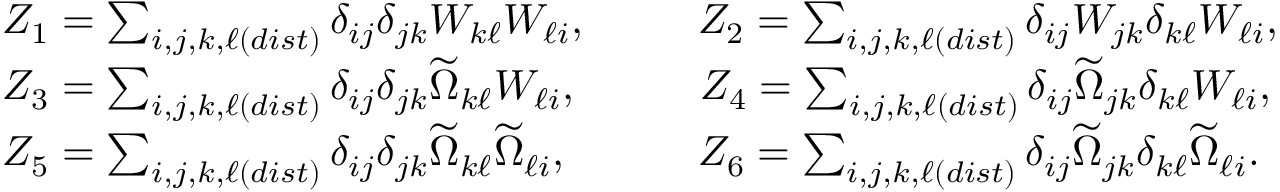Convert formula to latex. <formula><loc_0><loc_0><loc_500><loc_500>\begin{array} { r l } & { Z _ { 1 } = \sum _ { i , j , k , \ell ( d i s t ) } \delta _ { i j } \delta _ { j k } W _ { k \ell } W _ { \ell i } , \quad \, Z _ { 2 } = \sum _ { i , j , k , \ell ( d i s t ) } \delta _ { i j } W _ { j k } \delta _ { k \ell } W _ { \ell i } , } \\ & { Z _ { 3 } = \sum _ { i , j , k , \ell ( d i s t ) } \delta _ { i j } \delta _ { j k } \widetilde { \Omega } _ { k \ell } W _ { \ell i } , \quad \, Z _ { 4 } = \sum _ { i , j , k , \ell ( d i s t ) } \delta _ { i j } \widetilde { \Omega } _ { j k } \delta _ { k \ell } W _ { \ell i } , } \\ & { Z _ { 5 } = \sum _ { i , j , k , \ell ( d i s t ) } \delta _ { i j } \delta _ { j k } \widetilde { \Omega } _ { k \ell } \widetilde { \Omega } _ { \ell i } , \quad Z _ { 6 } = \sum _ { i , j , k , \ell ( d i s t ) } \delta _ { i j } \widetilde { \Omega } _ { j k } \delta _ { k \ell } \widetilde { \Omega } _ { \ell i } . } \end{array}</formula> 